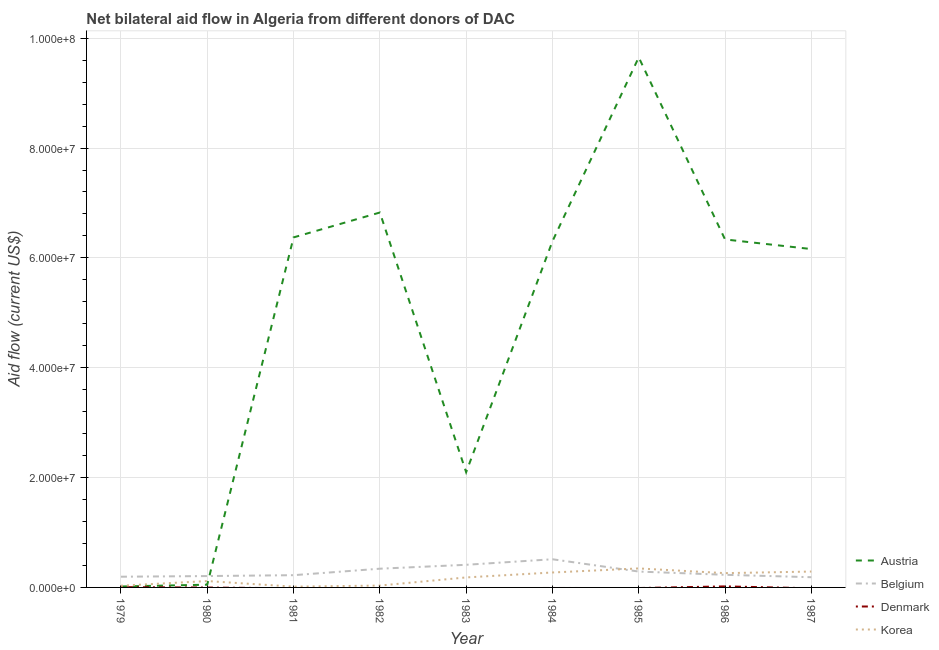What is the amount of aid given by belgium in 1987?
Offer a terse response. 1.86e+06. Across all years, what is the maximum amount of aid given by austria?
Keep it short and to the point. 9.65e+07. Across all years, what is the minimum amount of aid given by austria?
Keep it short and to the point. 1.70e+05. In which year was the amount of aid given by austria maximum?
Your response must be concise. 1985. What is the total amount of aid given by belgium in the graph?
Your answer should be compact. 2.60e+07. What is the difference between the amount of aid given by austria in 1981 and that in 1983?
Your response must be concise. 4.28e+07. What is the difference between the amount of aid given by korea in 1979 and the amount of aid given by denmark in 1980?
Your answer should be compact. 3.10e+05. What is the average amount of aid given by korea per year?
Provide a short and direct response. 1.72e+06. In the year 1981, what is the difference between the amount of aid given by austria and amount of aid given by belgium?
Provide a succinct answer. 6.15e+07. In how many years, is the amount of aid given by denmark greater than 64000000 US$?
Provide a succinct answer. 0. What is the ratio of the amount of aid given by austria in 1983 to that in 1986?
Ensure brevity in your answer.  0.33. Is the amount of aid given by korea in 1983 less than that in 1987?
Give a very brief answer. Yes. What is the difference between the highest and the second highest amount of aid given by korea?
Provide a short and direct response. 5.70e+05. What is the difference between the highest and the lowest amount of aid given by austria?
Offer a terse response. 9.63e+07. In how many years, is the amount of aid given by denmark greater than the average amount of aid given by denmark taken over all years?
Offer a terse response. 2. Is it the case that in every year, the sum of the amount of aid given by austria and amount of aid given by belgium is greater than the amount of aid given by denmark?
Your answer should be compact. Yes. Does the amount of aid given by denmark monotonically increase over the years?
Offer a terse response. No. Is the amount of aid given by denmark strictly greater than the amount of aid given by korea over the years?
Provide a short and direct response. No. Does the graph contain any zero values?
Offer a terse response. Yes. Does the graph contain grids?
Offer a terse response. Yes. Where does the legend appear in the graph?
Provide a succinct answer. Bottom right. How many legend labels are there?
Give a very brief answer. 4. What is the title of the graph?
Ensure brevity in your answer.  Net bilateral aid flow in Algeria from different donors of DAC. What is the label or title of the Y-axis?
Give a very brief answer. Aid flow (current US$). What is the Aid flow (current US$) of Belgium in 1979?
Offer a very short reply. 1.95e+06. What is the Aid flow (current US$) of Denmark in 1979?
Provide a short and direct response. 5.00e+04. What is the Aid flow (current US$) in Korea in 1979?
Make the answer very short. 3.10e+05. What is the Aid flow (current US$) of Austria in 1980?
Keep it short and to the point. 5.00e+05. What is the Aid flow (current US$) of Belgium in 1980?
Your answer should be compact. 2.07e+06. What is the Aid flow (current US$) in Denmark in 1980?
Provide a succinct answer. 0. What is the Aid flow (current US$) of Korea in 1980?
Provide a succinct answer. 1.16e+06. What is the Aid flow (current US$) of Austria in 1981?
Your answer should be compact. 6.37e+07. What is the Aid flow (current US$) in Belgium in 1981?
Your answer should be very brief. 2.23e+06. What is the Aid flow (current US$) in Denmark in 1981?
Offer a very short reply. 0. What is the Aid flow (current US$) in Austria in 1982?
Offer a terse response. 6.83e+07. What is the Aid flow (current US$) in Belgium in 1982?
Your response must be concise. 3.41e+06. What is the Aid flow (current US$) of Austria in 1983?
Offer a very short reply. 2.10e+07. What is the Aid flow (current US$) in Belgium in 1983?
Your response must be concise. 4.12e+06. What is the Aid flow (current US$) in Korea in 1983?
Provide a short and direct response. 1.82e+06. What is the Aid flow (current US$) in Austria in 1984?
Your response must be concise. 6.30e+07. What is the Aid flow (current US$) in Belgium in 1984?
Offer a terse response. 5.13e+06. What is the Aid flow (current US$) in Korea in 1984?
Offer a very short reply. 2.72e+06. What is the Aid flow (current US$) of Austria in 1985?
Make the answer very short. 9.65e+07. What is the Aid flow (current US$) in Belgium in 1985?
Your answer should be compact. 2.89e+06. What is the Aid flow (current US$) in Korea in 1985?
Offer a terse response. 3.46e+06. What is the Aid flow (current US$) of Austria in 1986?
Keep it short and to the point. 6.34e+07. What is the Aid flow (current US$) of Belgium in 1986?
Ensure brevity in your answer.  2.30e+06. What is the Aid flow (current US$) of Denmark in 1986?
Your response must be concise. 1.90e+05. What is the Aid flow (current US$) of Korea in 1986?
Provide a succinct answer. 2.60e+06. What is the Aid flow (current US$) of Austria in 1987?
Ensure brevity in your answer.  6.16e+07. What is the Aid flow (current US$) in Belgium in 1987?
Your response must be concise. 1.86e+06. What is the Aid flow (current US$) of Denmark in 1987?
Offer a very short reply. 0. What is the Aid flow (current US$) in Korea in 1987?
Make the answer very short. 2.89e+06. Across all years, what is the maximum Aid flow (current US$) of Austria?
Provide a short and direct response. 9.65e+07. Across all years, what is the maximum Aid flow (current US$) of Belgium?
Your answer should be compact. 5.13e+06. Across all years, what is the maximum Aid flow (current US$) in Denmark?
Provide a succinct answer. 1.90e+05. Across all years, what is the maximum Aid flow (current US$) of Korea?
Give a very brief answer. 3.46e+06. Across all years, what is the minimum Aid flow (current US$) of Belgium?
Your answer should be compact. 1.86e+06. What is the total Aid flow (current US$) in Austria in the graph?
Offer a terse response. 4.38e+08. What is the total Aid flow (current US$) in Belgium in the graph?
Your answer should be compact. 2.60e+07. What is the total Aid flow (current US$) in Denmark in the graph?
Offer a terse response. 2.40e+05. What is the total Aid flow (current US$) of Korea in the graph?
Your answer should be compact. 1.54e+07. What is the difference between the Aid flow (current US$) in Austria in 1979 and that in 1980?
Your response must be concise. -3.30e+05. What is the difference between the Aid flow (current US$) in Belgium in 1979 and that in 1980?
Offer a very short reply. -1.20e+05. What is the difference between the Aid flow (current US$) of Korea in 1979 and that in 1980?
Make the answer very short. -8.50e+05. What is the difference between the Aid flow (current US$) in Austria in 1979 and that in 1981?
Offer a very short reply. -6.36e+07. What is the difference between the Aid flow (current US$) of Belgium in 1979 and that in 1981?
Ensure brevity in your answer.  -2.80e+05. What is the difference between the Aid flow (current US$) in Korea in 1979 and that in 1981?
Give a very brief answer. 1.70e+05. What is the difference between the Aid flow (current US$) in Austria in 1979 and that in 1982?
Offer a very short reply. -6.81e+07. What is the difference between the Aid flow (current US$) of Belgium in 1979 and that in 1982?
Offer a very short reply. -1.46e+06. What is the difference between the Aid flow (current US$) in Austria in 1979 and that in 1983?
Provide a short and direct response. -2.08e+07. What is the difference between the Aid flow (current US$) of Belgium in 1979 and that in 1983?
Your answer should be very brief. -2.17e+06. What is the difference between the Aid flow (current US$) of Korea in 1979 and that in 1983?
Make the answer very short. -1.51e+06. What is the difference between the Aid flow (current US$) in Austria in 1979 and that in 1984?
Keep it short and to the point. -6.28e+07. What is the difference between the Aid flow (current US$) of Belgium in 1979 and that in 1984?
Your response must be concise. -3.18e+06. What is the difference between the Aid flow (current US$) in Korea in 1979 and that in 1984?
Your response must be concise. -2.41e+06. What is the difference between the Aid flow (current US$) of Austria in 1979 and that in 1985?
Your answer should be compact. -9.63e+07. What is the difference between the Aid flow (current US$) in Belgium in 1979 and that in 1985?
Ensure brevity in your answer.  -9.40e+05. What is the difference between the Aid flow (current US$) of Korea in 1979 and that in 1985?
Provide a succinct answer. -3.15e+06. What is the difference between the Aid flow (current US$) of Austria in 1979 and that in 1986?
Give a very brief answer. -6.32e+07. What is the difference between the Aid flow (current US$) in Belgium in 1979 and that in 1986?
Your answer should be compact. -3.50e+05. What is the difference between the Aid flow (current US$) of Korea in 1979 and that in 1986?
Your answer should be very brief. -2.29e+06. What is the difference between the Aid flow (current US$) in Austria in 1979 and that in 1987?
Keep it short and to the point. -6.14e+07. What is the difference between the Aid flow (current US$) of Belgium in 1979 and that in 1987?
Provide a succinct answer. 9.00e+04. What is the difference between the Aid flow (current US$) in Korea in 1979 and that in 1987?
Give a very brief answer. -2.58e+06. What is the difference between the Aid flow (current US$) in Austria in 1980 and that in 1981?
Offer a terse response. -6.32e+07. What is the difference between the Aid flow (current US$) in Belgium in 1980 and that in 1981?
Keep it short and to the point. -1.60e+05. What is the difference between the Aid flow (current US$) in Korea in 1980 and that in 1981?
Your response must be concise. 1.02e+06. What is the difference between the Aid flow (current US$) of Austria in 1980 and that in 1982?
Your response must be concise. -6.78e+07. What is the difference between the Aid flow (current US$) in Belgium in 1980 and that in 1982?
Offer a very short reply. -1.34e+06. What is the difference between the Aid flow (current US$) in Korea in 1980 and that in 1982?
Give a very brief answer. 8.20e+05. What is the difference between the Aid flow (current US$) in Austria in 1980 and that in 1983?
Provide a short and direct response. -2.05e+07. What is the difference between the Aid flow (current US$) of Belgium in 1980 and that in 1983?
Your answer should be compact. -2.05e+06. What is the difference between the Aid flow (current US$) in Korea in 1980 and that in 1983?
Offer a terse response. -6.60e+05. What is the difference between the Aid flow (current US$) in Austria in 1980 and that in 1984?
Offer a terse response. -6.25e+07. What is the difference between the Aid flow (current US$) in Belgium in 1980 and that in 1984?
Provide a succinct answer. -3.06e+06. What is the difference between the Aid flow (current US$) of Korea in 1980 and that in 1984?
Make the answer very short. -1.56e+06. What is the difference between the Aid flow (current US$) of Austria in 1980 and that in 1985?
Provide a succinct answer. -9.60e+07. What is the difference between the Aid flow (current US$) in Belgium in 1980 and that in 1985?
Offer a terse response. -8.20e+05. What is the difference between the Aid flow (current US$) of Korea in 1980 and that in 1985?
Offer a very short reply. -2.30e+06. What is the difference between the Aid flow (current US$) of Austria in 1980 and that in 1986?
Your response must be concise. -6.29e+07. What is the difference between the Aid flow (current US$) in Korea in 1980 and that in 1986?
Your answer should be very brief. -1.44e+06. What is the difference between the Aid flow (current US$) of Austria in 1980 and that in 1987?
Your answer should be very brief. -6.11e+07. What is the difference between the Aid flow (current US$) in Korea in 1980 and that in 1987?
Provide a succinct answer. -1.73e+06. What is the difference between the Aid flow (current US$) in Austria in 1981 and that in 1982?
Give a very brief answer. -4.53e+06. What is the difference between the Aid flow (current US$) in Belgium in 1981 and that in 1982?
Offer a very short reply. -1.18e+06. What is the difference between the Aid flow (current US$) of Korea in 1981 and that in 1982?
Make the answer very short. -2.00e+05. What is the difference between the Aid flow (current US$) in Austria in 1981 and that in 1983?
Make the answer very short. 4.28e+07. What is the difference between the Aid flow (current US$) in Belgium in 1981 and that in 1983?
Provide a short and direct response. -1.89e+06. What is the difference between the Aid flow (current US$) of Korea in 1981 and that in 1983?
Provide a short and direct response. -1.68e+06. What is the difference between the Aid flow (current US$) of Austria in 1981 and that in 1984?
Keep it short and to the point. 7.10e+05. What is the difference between the Aid flow (current US$) in Belgium in 1981 and that in 1984?
Keep it short and to the point. -2.90e+06. What is the difference between the Aid flow (current US$) of Korea in 1981 and that in 1984?
Provide a succinct answer. -2.58e+06. What is the difference between the Aid flow (current US$) in Austria in 1981 and that in 1985?
Ensure brevity in your answer.  -3.28e+07. What is the difference between the Aid flow (current US$) in Belgium in 1981 and that in 1985?
Keep it short and to the point. -6.60e+05. What is the difference between the Aid flow (current US$) in Korea in 1981 and that in 1985?
Provide a succinct answer. -3.32e+06. What is the difference between the Aid flow (current US$) in Korea in 1981 and that in 1986?
Offer a very short reply. -2.46e+06. What is the difference between the Aid flow (current US$) in Austria in 1981 and that in 1987?
Give a very brief answer. 2.12e+06. What is the difference between the Aid flow (current US$) of Belgium in 1981 and that in 1987?
Give a very brief answer. 3.70e+05. What is the difference between the Aid flow (current US$) in Korea in 1981 and that in 1987?
Provide a short and direct response. -2.75e+06. What is the difference between the Aid flow (current US$) in Austria in 1982 and that in 1983?
Keep it short and to the point. 4.73e+07. What is the difference between the Aid flow (current US$) in Belgium in 1982 and that in 1983?
Offer a terse response. -7.10e+05. What is the difference between the Aid flow (current US$) of Korea in 1982 and that in 1983?
Your answer should be very brief. -1.48e+06. What is the difference between the Aid flow (current US$) in Austria in 1982 and that in 1984?
Your answer should be compact. 5.24e+06. What is the difference between the Aid flow (current US$) in Belgium in 1982 and that in 1984?
Ensure brevity in your answer.  -1.72e+06. What is the difference between the Aid flow (current US$) in Korea in 1982 and that in 1984?
Provide a succinct answer. -2.38e+06. What is the difference between the Aid flow (current US$) of Austria in 1982 and that in 1985?
Make the answer very short. -2.82e+07. What is the difference between the Aid flow (current US$) of Belgium in 1982 and that in 1985?
Your answer should be very brief. 5.20e+05. What is the difference between the Aid flow (current US$) of Korea in 1982 and that in 1985?
Ensure brevity in your answer.  -3.12e+06. What is the difference between the Aid flow (current US$) in Austria in 1982 and that in 1986?
Keep it short and to the point. 4.90e+06. What is the difference between the Aid flow (current US$) of Belgium in 1982 and that in 1986?
Your response must be concise. 1.11e+06. What is the difference between the Aid flow (current US$) of Korea in 1982 and that in 1986?
Give a very brief answer. -2.26e+06. What is the difference between the Aid flow (current US$) in Austria in 1982 and that in 1987?
Your answer should be very brief. 6.65e+06. What is the difference between the Aid flow (current US$) of Belgium in 1982 and that in 1987?
Ensure brevity in your answer.  1.55e+06. What is the difference between the Aid flow (current US$) of Korea in 1982 and that in 1987?
Provide a succinct answer. -2.55e+06. What is the difference between the Aid flow (current US$) of Austria in 1983 and that in 1984?
Your answer should be compact. -4.20e+07. What is the difference between the Aid flow (current US$) in Belgium in 1983 and that in 1984?
Keep it short and to the point. -1.01e+06. What is the difference between the Aid flow (current US$) of Korea in 1983 and that in 1984?
Give a very brief answer. -9.00e+05. What is the difference between the Aid flow (current US$) of Austria in 1983 and that in 1985?
Offer a very short reply. -7.55e+07. What is the difference between the Aid flow (current US$) in Belgium in 1983 and that in 1985?
Provide a short and direct response. 1.23e+06. What is the difference between the Aid flow (current US$) in Korea in 1983 and that in 1985?
Provide a succinct answer. -1.64e+06. What is the difference between the Aid flow (current US$) in Austria in 1983 and that in 1986?
Ensure brevity in your answer.  -4.24e+07. What is the difference between the Aid flow (current US$) in Belgium in 1983 and that in 1986?
Give a very brief answer. 1.82e+06. What is the difference between the Aid flow (current US$) of Korea in 1983 and that in 1986?
Your answer should be compact. -7.80e+05. What is the difference between the Aid flow (current US$) of Austria in 1983 and that in 1987?
Offer a very short reply. -4.06e+07. What is the difference between the Aid flow (current US$) in Belgium in 1983 and that in 1987?
Ensure brevity in your answer.  2.26e+06. What is the difference between the Aid flow (current US$) in Korea in 1983 and that in 1987?
Provide a succinct answer. -1.07e+06. What is the difference between the Aid flow (current US$) in Austria in 1984 and that in 1985?
Your response must be concise. -3.35e+07. What is the difference between the Aid flow (current US$) in Belgium in 1984 and that in 1985?
Provide a succinct answer. 2.24e+06. What is the difference between the Aid flow (current US$) of Korea in 1984 and that in 1985?
Your answer should be compact. -7.40e+05. What is the difference between the Aid flow (current US$) in Belgium in 1984 and that in 1986?
Your answer should be very brief. 2.83e+06. What is the difference between the Aid flow (current US$) of Austria in 1984 and that in 1987?
Provide a short and direct response. 1.41e+06. What is the difference between the Aid flow (current US$) of Belgium in 1984 and that in 1987?
Ensure brevity in your answer.  3.27e+06. What is the difference between the Aid flow (current US$) of Austria in 1985 and that in 1986?
Keep it short and to the point. 3.32e+07. What is the difference between the Aid flow (current US$) in Belgium in 1985 and that in 1986?
Make the answer very short. 5.90e+05. What is the difference between the Aid flow (current US$) in Korea in 1985 and that in 1986?
Offer a terse response. 8.60e+05. What is the difference between the Aid flow (current US$) in Austria in 1985 and that in 1987?
Your answer should be compact. 3.49e+07. What is the difference between the Aid flow (current US$) of Belgium in 1985 and that in 1987?
Your answer should be very brief. 1.03e+06. What is the difference between the Aid flow (current US$) in Korea in 1985 and that in 1987?
Offer a terse response. 5.70e+05. What is the difference between the Aid flow (current US$) of Austria in 1986 and that in 1987?
Your answer should be very brief. 1.75e+06. What is the difference between the Aid flow (current US$) in Korea in 1986 and that in 1987?
Ensure brevity in your answer.  -2.90e+05. What is the difference between the Aid flow (current US$) of Austria in 1979 and the Aid flow (current US$) of Belgium in 1980?
Provide a succinct answer. -1.90e+06. What is the difference between the Aid flow (current US$) of Austria in 1979 and the Aid flow (current US$) of Korea in 1980?
Offer a terse response. -9.90e+05. What is the difference between the Aid flow (current US$) in Belgium in 1979 and the Aid flow (current US$) in Korea in 1980?
Offer a terse response. 7.90e+05. What is the difference between the Aid flow (current US$) in Denmark in 1979 and the Aid flow (current US$) in Korea in 1980?
Provide a short and direct response. -1.11e+06. What is the difference between the Aid flow (current US$) of Austria in 1979 and the Aid flow (current US$) of Belgium in 1981?
Give a very brief answer. -2.06e+06. What is the difference between the Aid flow (current US$) of Belgium in 1979 and the Aid flow (current US$) of Korea in 1981?
Ensure brevity in your answer.  1.81e+06. What is the difference between the Aid flow (current US$) of Austria in 1979 and the Aid flow (current US$) of Belgium in 1982?
Your answer should be compact. -3.24e+06. What is the difference between the Aid flow (current US$) of Belgium in 1979 and the Aid flow (current US$) of Korea in 1982?
Make the answer very short. 1.61e+06. What is the difference between the Aid flow (current US$) of Austria in 1979 and the Aid flow (current US$) of Belgium in 1983?
Provide a succinct answer. -3.95e+06. What is the difference between the Aid flow (current US$) of Austria in 1979 and the Aid flow (current US$) of Korea in 1983?
Keep it short and to the point. -1.65e+06. What is the difference between the Aid flow (current US$) of Denmark in 1979 and the Aid flow (current US$) of Korea in 1983?
Keep it short and to the point. -1.77e+06. What is the difference between the Aid flow (current US$) in Austria in 1979 and the Aid flow (current US$) in Belgium in 1984?
Offer a terse response. -4.96e+06. What is the difference between the Aid flow (current US$) of Austria in 1979 and the Aid flow (current US$) of Korea in 1984?
Provide a succinct answer. -2.55e+06. What is the difference between the Aid flow (current US$) of Belgium in 1979 and the Aid flow (current US$) of Korea in 1984?
Your answer should be compact. -7.70e+05. What is the difference between the Aid flow (current US$) of Denmark in 1979 and the Aid flow (current US$) of Korea in 1984?
Make the answer very short. -2.67e+06. What is the difference between the Aid flow (current US$) of Austria in 1979 and the Aid flow (current US$) of Belgium in 1985?
Your answer should be very brief. -2.72e+06. What is the difference between the Aid flow (current US$) of Austria in 1979 and the Aid flow (current US$) of Korea in 1985?
Offer a very short reply. -3.29e+06. What is the difference between the Aid flow (current US$) in Belgium in 1979 and the Aid flow (current US$) in Korea in 1985?
Your answer should be very brief. -1.51e+06. What is the difference between the Aid flow (current US$) in Denmark in 1979 and the Aid flow (current US$) in Korea in 1985?
Provide a succinct answer. -3.41e+06. What is the difference between the Aid flow (current US$) in Austria in 1979 and the Aid flow (current US$) in Belgium in 1986?
Your answer should be very brief. -2.13e+06. What is the difference between the Aid flow (current US$) of Austria in 1979 and the Aid flow (current US$) of Korea in 1986?
Offer a terse response. -2.43e+06. What is the difference between the Aid flow (current US$) in Belgium in 1979 and the Aid flow (current US$) in Denmark in 1986?
Your response must be concise. 1.76e+06. What is the difference between the Aid flow (current US$) in Belgium in 1979 and the Aid flow (current US$) in Korea in 1986?
Keep it short and to the point. -6.50e+05. What is the difference between the Aid flow (current US$) in Denmark in 1979 and the Aid flow (current US$) in Korea in 1986?
Provide a succinct answer. -2.55e+06. What is the difference between the Aid flow (current US$) in Austria in 1979 and the Aid flow (current US$) in Belgium in 1987?
Offer a very short reply. -1.69e+06. What is the difference between the Aid flow (current US$) in Austria in 1979 and the Aid flow (current US$) in Korea in 1987?
Offer a terse response. -2.72e+06. What is the difference between the Aid flow (current US$) of Belgium in 1979 and the Aid flow (current US$) of Korea in 1987?
Your response must be concise. -9.40e+05. What is the difference between the Aid flow (current US$) in Denmark in 1979 and the Aid flow (current US$) in Korea in 1987?
Provide a succinct answer. -2.84e+06. What is the difference between the Aid flow (current US$) in Austria in 1980 and the Aid flow (current US$) in Belgium in 1981?
Offer a very short reply. -1.73e+06. What is the difference between the Aid flow (current US$) of Belgium in 1980 and the Aid flow (current US$) of Korea in 1981?
Make the answer very short. 1.93e+06. What is the difference between the Aid flow (current US$) in Austria in 1980 and the Aid flow (current US$) in Belgium in 1982?
Offer a very short reply. -2.91e+06. What is the difference between the Aid flow (current US$) of Austria in 1980 and the Aid flow (current US$) of Korea in 1982?
Make the answer very short. 1.60e+05. What is the difference between the Aid flow (current US$) in Belgium in 1980 and the Aid flow (current US$) in Korea in 1982?
Keep it short and to the point. 1.73e+06. What is the difference between the Aid flow (current US$) of Austria in 1980 and the Aid flow (current US$) of Belgium in 1983?
Ensure brevity in your answer.  -3.62e+06. What is the difference between the Aid flow (current US$) in Austria in 1980 and the Aid flow (current US$) in Korea in 1983?
Offer a very short reply. -1.32e+06. What is the difference between the Aid flow (current US$) in Austria in 1980 and the Aid flow (current US$) in Belgium in 1984?
Provide a succinct answer. -4.63e+06. What is the difference between the Aid flow (current US$) in Austria in 1980 and the Aid flow (current US$) in Korea in 1984?
Offer a terse response. -2.22e+06. What is the difference between the Aid flow (current US$) in Belgium in 1980 and the Aid flow (current US$) in Korea in 1984?
Your response must be concise. -6.50e+05. What is the difference between the Aid flow (current US$) in Austria in 1980 and the Aid flow (current US$) in Belgium in 1985?
Keep it short and to the point. -2.39e+06. What is the difference between the Aid flow (current US$) in Austria in 1980 and the Aid flow (current US$) in Korea in 1985?
Provide a succinct answer. -2.96e+06. What is the difference between the Aid flow (current US$) in Belgium in 1980 and the Aid flow (current US$) in Korea in 1985?
Offer a terse response. -1.39e+06. What is the difference between the Aid flow (current US$) in Austria in 1980 and the Aid flow (current US$) in Belgium in 1986?
Make the answer very short. -1.80e+06. What is the difference between the Aid flow (current US$) of Austria in 1980 and the Aid flow (current US$) of Denmark in 1986?
Give a very brief answer. 3.10e+05. What is the difference between the Aid flow (current US$) of Austria in 1980 and the Aid flow (current US$) of Korea in 1986?
Provide a succinct answer. -2.10e+06. What is the difference between the Aid flow (current US$) in Belgium in 1980 and the Aid flow (current US$) in Denmark in 1986?
Your answer should be very brief. 1.88e+06. What is the difference between the Aid flow (current US$) of Belgium in 1980 and the Aid flow (current US$) of Korea in 1986?
Your answer should be very brief. -5.30e+05. What is the difference between the Aid flow (current US$) in Austria in 1980 and the Aid flow (current US$) in Belgium in 1987?
Your answer should be very brief. -1.36e+06. What is the difference between the Aid flow (current US$) in Austria in 1980 and the Aid flow (current US$) in Korea in 1987?
Your response must be concise. -2.39e+06. What is the difference between the Aid flow (current US$) of Belgium in 1980 and the Aid flow (current US$) of Korea in 1987?
Your answer should be very brief. -8.20e+05. What is the difference between the Aid flow (current US$) in Austria in 1981 and the Aid flow (current US$) in Belgium in 1982?
Provide a succinct answer. 6.03e+07. What is the difference between the Aid flow (current US$) in Austria in 1981 and the Aid flow (current US$) in Korea in 1982?
Your answer should be very brief. 6.34e+07. What is the difference between the Aid flow (current US$) in Belgium in 1981 and the Aid flow (current US$) in Korea in 1982?
Provide a short and direct response. 1.89e+06. What is the difference between the Aid flow (current US$) in Austria in 1981 and the Aid flow (current US$) in Belgium in 1983?
Keep it short and to the point. 5.96e+07. What is the difference between the Aid flow (current US$) in Austria in 1981 and the Aid flow (current US$) in Korea in 1983?
Your answer should be compact. 6.19e+07. What is the difference between the Aid flow (current US$) in Belgium in 1981 and the Aid flow (current US$) in Korea in 1983?
Ensure brevity in your answer.  4.10e+05. What is the difference between the Aid flow (current US$) in Austria in 1981 and the Aid flow (current US$) in Belgium in 1984?
Make the answer very short. 5.86e+07. What is the difference between the Aid flow (current US$) of Austria in 1981 and the Aid flow (current US$) of Korea in 1984?
Make the answer very short. 6.10e+07. What is the difference between the Aid flow (current US$) in Belgium in 1981 and the Aid flow (current US$) in Korea in 1984?
Your answer should be compact. -4.90e+05. What is the difference between the Aid flow (current US$) of Austria in 1981 and the Aid flow (current US$) of Belgium in 1985?
Keep it short and to the point. 6.08e+07. What is the difference between the Aid flow (current US$) in Austria in 1981 and the Aid flow (current US$) in Korea in 1985?
Keep it short and to the point. 6.03e+07. What is the difference between the Aid flow (current US$) of Belgium in 1981 and the Aid flow (current US$) of Korea in 1985?
Give a very brief answer. -1.23e+06. What is the difference between the Aid flow (current US$) of Austria in 1981 and the Aid flow (current US$) of Belgium in 1986?
Provide a short and direct response. 6.14e+07. What is the difference between the Aid flow (current US$) in Austria in 1981 and the Aid flow (current US$) in Denmark in 1986?
Your response must be concise. 6.35e+07. What is the difference between the Aid flow (current US$) of Austria in 1981 and the Aid flow (current US$) of Korea in 1986?
Keep it short and to the point. 6.11e+07. What is the difference between the Aid flow (current US$) in Belgium in 1981 and the Aid flow (current US$) in Denmark in 1986?
Provide a short and direct response. 2.04e+06. What is the difference between the Aid flow (current US$) in Belgium in 1981 and the Aid flow (current US$) in Korea in 1986?
Offer a very short reply. -3.70e+05. What is the difference between the Aid flow (current US$) of Austria in 1981 and the Aid flow (current US$) of Belgium in 1987?
Your answer should be compact. 6.19e+07. What is the difference between the Aid flow (current US$) in Austria in 1981 and the Aid flow (current US$) in Korea in 1987?
Keep it short and to the point. 6.08e+07. What is the difference between the Aid flow (current US$) of Belgium in 1981 and the Aid flow (current US$) of Korea in 1987?
Offer a very short reply. -6.60e+05. What is the difference between the Aid flow (current US$) in Austria in 1982 and the Aid flow (current US$) in Belgium in 1983?
Your answer should be compact. 6.41e+07. What is the difference between the Aid flow (current US$) in Austria in 1982 and the Aid flow (current US$) in Korea in 1983?
Ensure brevity in your answer.  6.64e+07. What is the difference between the Aid flow (current US$) in Belgium in 1982 and the Aid flow (current US$) in Korea in 1983?
Make the answer very short. 1.59e+06. What is the difference between the Aid flow (current US$) of Austria in 1982 and the Aid flow (current US$) of Belgium in 1984?
Your answer should be compact. 6.31e+07. What is the difference between the Aid flow (current US$) of Austria in 1982 and the Aid flow (current US$) of Korea in 1984?
Keep it short and to the point. 6.55e+07. What is the difference between the Aid flow (current US$) of Belgium in 1982 and the Aid flow (current US$) of Korea in 1984?
Provide a succinct answer. 6.90e+05. What is the difference between the Aid flow (current US$) in Austria in 1982 and the Aid flow (current US$) in Belgium in 1985?
Ensure brevity in your answer.  6.54e+07. What is the difference between the Aid flow (current US$) in Austria in 1982 and the Aid flow (current US$) in Korea in 1985?
Your response must be concise. 6.48e+07. What is the difference between the Aid flow (current US$) in Belgium in 1982 and the Aid flow (current US$) in Korea in 1985?
Make the answer very short. -5.00e+04. What is the difference between the Aid flow (current US$) of Austria in 1982 and the Aid flow (current US$) of Belgium in 1986?
Give a very brief answer. 6.60e+07. What is the difference between the Aid flow (current US$) of Austria in 1982 and the Aid flow (current US$) of Denmark in 1986?
Offer a terse response. 6.81e+07. What is the difference between the Aid flow (current US$) of Austria in 1982 and the Aid flow (current US$) of Korea in 1986?
Provide a short and direct response. 6.57e+07. What is the difference between the Aid flow (current US$) in Belgium in 1982 and the Aid flow (current US$) in Denmark in 1986?
Your answer should be compact. 3.22e+06. What is the difference between the Aid flow (current US$) in Belgium in 1982 and the Aid flow (current US$) in Korea in 1986?
Give a very brief answer. 8.10e+05. What is the difference between the Aid flow (current US$) in Austria in 1982 and the Aid flow (current US$) in Belgium in 1987?
Keep it short and to the point. 6.64e+07. What is the difference between the Aid flow (current US$) in Austria in 1982 and the Aid flow (current US$) in Korea in 1987?
Provide a short and direct response. 6.54e+07. What is the difference between the Aid flow (current US$) in Belgium in 1982 and the Aid flow (current US$) in Korea in 1987?
Give a very brief answer. 5.20e+05. What is the difference between the Aid flow (current US$) in Austria in 1983 and the Aid flow (current US$) in Belgium in 1984?
Provide a succinct answer. 1.58e+07. What is the difference between the Aid flow (current US$) of Austria in 1983 and the Aid flow (current US$) of Korea in 1984?
Make the answer very short. 1.83e+07. What is the difference between the Aid flow (current US$) of Belgium in 1983 and the Aid flow (current US$) of Korea in 1984?
Ensure brevity in your answer.  1.40e+06. What is the difference between the Aid flow (current US$) of Austria in 1983 and the Aid flow (current US$) of Belgium in 1985?
Give a very brief answer. 1.81e+07. What is the difference between the Aid flow (current US$) in Austria in 1983 and the Aid flow (current US$) in Korea in 1985?
Keep it short and to the point. 1.75e+07. What is the difference between the Aid flow (current US$) in Belgium in 1983 and the Aid flow (current US$) in Korea in 1985?
Ensure brevity in your answer.  6.60e+05. What is the difference between the Aid flow (current US$) of Austria in 1983 and the Aid flow (current US$) of Belgium in 1986?
Your response must be concise. 1.87e+07. What is the difference between the Aid flow (current US$) of Austria in 1983 and the Aid flow (current US$) of Denmark in 1986?
Ensure brevity in your answer.  2.08e+07. What is the difference between the Aid flow (current US$) in Austria in 1983 and the Aid flow (current US$) in Korea in 1986?
Your answer should be compact. 1.84e+07. What is the difference between the Aid flow (current US$) in Belgium in 1983 and the Aid flow (current US$) in Denmark in 1986?
Your answer should be very brief. 3.93e+06. What is the difference between the Aid flow (current US$) in Belgium in 1983 and the Aid flow (current US$) in Korea in 1986?
Make the answer very short. 1.52e+06. What is the difference between the Aid flow (current US$) of Austria in 1983 and the Aid flow (current US$) of Belgium in 1987?
Offer a very short reply. 1.91e+07. What is the difference between the Aid flow (current US$) in Austria in 1983 and the Aid flow (current US$) in Korea in 1987?
Offer a very short reply. 1.81e+07. What is the difference between the Aid flow (current US$) in Belgium in 1983 and the Aid flow (current US$) in Korea in 1987?
Your response must be concise. 1.23e+06. What is the difference between the Aid flow (current US$) in Austria in 1984 and the Aid flow (current US$) in Belgium in 1985?
Offer a terse response. 6.01e+07. What is the difference between the Aid flow (current US$) of Austria in 1984 and the Aid flow (current US$) of Korea in 1985?
Keep it short and to the point. 5.96e+07. What is the difference between the Aid flow (current US$) of Belgium in 1984 and the Aid flow (current US$) of Korea in 1985?
Offer a very short reply. 1.67e+06. What is the difference between the Aid flow (current US$) in Austria in 1984 and the Aid flow (current US$) in Belgium in 1986?
Your response must be concise. 6.07e+07. What is the difference between the Aid flow (current US$) in Austria in 1984 and the Aid flow (current US$) in Denmark in 1986?
Give a very brief answer. 6.28e+07. What is the difference between the Aid flow (current US$) in Austria in 1984 and the Aid flow (current US$) in Korea in 1986?
Give a very brief answer. 6.04e+07. What is the difference between the Aid flow (current US$) in Belgium in 1984 and the Aid flow (current US$) in Denmark in 1986?
Your response must be concise. 4.94e+06. What is the difference between the Aid flow (current US$) of Belgium in 1984 and the Aid flow (current US$) of Korea in 1986?
Your response must be concise. 2.53e+06. What is the difference between the Aid flow (current US$) in Austria in 1984 and the Aid flow (current US$) in Belgium in 1987?
Give a very brief answer. 6.12e+07. What is the difference between the Aid flow (current US$) of Austria in 1984 and the Aid flow (current US$) of Korea in 1987?
Offer a very short reply. 6.01e+07. What is the difference between the Aid flow (current US$) in Belgium in 1984 and the Aid flow (current US$) in Korea in 1987?
Your response must be concise. 2.24e+06. What is the difference between the Aid flow (current US$) in Austria in 1985 and the Aid flow (current US$) in Belgium in 1986?
Keep it short and to the point. 9.42e+07. What is the difference between the Aid flow (current US$) in Austria in 1985 and the Aid flow (current US$) in Denmark in 1986?
Provide a succinct answer. 9.63e+07. What is the difference between the Aid flow (current US$) in Austria in 1985 and the Aid flow (current US$) in Korea in 1986?
Your answer should be very brief. 9.39e+07. What is the difference between the Aid flow (current US$) in Belgium in 1985 and the Aid flow (current US$) in Denmark in 1986?
Provide a short and direct response. 2.70e+06. What is the difference between the Aid flow (current US$) of Austria in 1985 and the Aid flow (current US$) of Belgium in 1987?
Provide a succinct answer. 9.46e+07. What is the difference between the Aid flow (current US$) in Austria in 1985 and the Aid flow (current US$) in Korea in 1987?
Make the answer very short. 9.36e+07. What is the difference between the Aid flow (current US$) of Austria in 1986 and the Aid flow (current US$) of Belgium in 1987?
Your response must be concise. 6.15e+07. What is the difference between the Aid flow (current US$) of Austria in 1986 and the Aid flow (current US$) of Korea in 1987?
Your answer should be compact. 6.05e+07. What is the difference between the Aid flow (current US$) in Belgium in 1986 and the Aid flow (current US$) in Korea in 1987?
Give a very brief answer. -5.90e+05. What is the difference between the Aid flow (current US$) in Denmark in 1986 and the Aid flow (current US$) in Korea in 1987?
Keep it short and to the point. -2.70e+06. What is the average Aid flow (current US$) of Austria per year?
Keep it short and to the point. 4.87e+07. What is the average Aid flow (current US$) of Belgium per year?
Give a very brief answer. 2.88e+06. What is the average Aid flow (current US$) of Denmark per year?
Make the answer very short. 2.67e+04. What is the average Aid flow (current US$) of Korea per year?
Make the answer very short. 1.72e+06. In the year 1979, what is the difference between the Aid flow (current US$) in Austria and Aid flow (current US$) in Belgium?
Offer a very short reply. -1.78e+06. In the year 1979, what is the difference between the Aid flow (current US$) in Austria and Aid flow (current US$) in Denmark?
Your response must be concise. 1.20e+05. In the year 1979, what is the difference between the Aid flow (current US$) of Belgium and Aid flow (current US$) of Denmark?
Provide a short and direct response. 1.90e+06. In the year 1979, what is the difference between the Aid flow (current US$) of Belgium and Aid flow (current US$) of Korea?
Ensure brevity in your answer.  1.64e+06. In the year 1980, what is the difference between the Aid flow (current US$) in Austria and Aid flow (current US$) in Belgium?
Your answer should be compact. -1.57e+06. In the year 1980, what is the difference between the Aid flow (current US$) of Austria and Aid flow (current US$) of Korea?
Ensure brevity in your answer.  -6.60e+05. In the year 1980, what is the difference between the Aid flow (current US$) of Belgium and Aid flow (current US$) of Korea?
Keep it short and to the point. 9.10e+05. In the year 1981, what is the difference between the Aid flow (current US$) in Austria and Aid flow (current US$) in Belgium?
Offer a very short reply. 6.15e+07. In the year 1981, what is the difference between the Aid flow (current US$) in Austria and Aid flow (current US$) in Korea?
Make the answer very short. 6.36e+07. In the year 1981, what is the difference between the Aid flow (current US$) in Belgium and Aid flow (current US$) in Korea?
Make the answer very short. 2.09e+06. In the year 1982, what is the difference between the Aid flow (current US$) of Austria and Aid flow (current US$) of Belgium?
Keep it short and to the point. 6.48e+07. In the year 1982, what is the difference between the Aid flow (current US$) in Austria and Aid flow (current US$) in Korea?
Your answer should be compact. 6.79e+07. In the year 1982, what is the difference between the Aid flow (current US$) of Belgium and Aid flow (current US$) of Korea?
Your answer should be compact. 3.07e+06. In the year 1983, what is the difference between the Aid flow (current US$) in Austria and Aid flow (current US$) in Belgium?
Give a very brief answer. 1.69e+07. In the year 1983, what is the difference between the Aid flow (current US$) of Austria and Aid flow (current US$) of Korea?
Ensure brevity in your answer.  1.92e+07. In the year 1983, what is the difference between the Aid flow (current US$) in Belgium and Aid flow (current US$) in Korea?
Provide a succinct answer. 2.30e+06. In the year 1984, what is the difference between the Aid flow (current US$) of Austria and Aid flow (current US$) of Belgium?
Keep it short and to the point. 5.79e+07. In the year 1984, what is the difference between the Aid flow (current US$) of Austria and Aid flow (current US$) of Korea?
Keep it short and to the point. 6.03e+07. In the year 1984, what is the difference between the Aid flow (current US$) of Belgium and Aid flow (current US$) of Korea?
Your answer should be compact. 2.41e+06. In the year 1985, what is the difference between the Aid flow (current US$) in Austria and Aid flow (current US$) in Belgium?
Ensure brevity in your answer.  9.36e+07. In the year 1985, what is the difference between the Aid flow (current US$) in Austria and Aid flow (current US$) in Korea?
Provide a short and direct response. 9.30e+07. In the year 1985, what is the difference between the Aid flow (current US$) of Belgium and Aid flow (current US$) of Korea?
Your answer should be compact. -5.70e+05. In the year 1986, what is the difference between the Aid flow (current US$) in Austria and Aid flow (current US$) in Belgium?
Provide a short and direct response. 6.11e+07. In the year 1986, what is the difference between the Aid flow (current US$) in Austria and Aid flow (current US$) in Denmark?
Offer a terse response. 6.32e+07. In the year 1986, what is the difference between the Aid flow (current US$) in Austria and Aid flow (current US$) in Korea?
Make the answer very short. 6.08e+07. In the year 1986, what is the difference between the Aid flow (current US$) in Belgium and Aid flow (current US$) in Denmark?
Keep it short and to the point. 2.11e+06. In the year 1986, what is the difference between the Aid flow (current US$) of Belgium and Aid flow (current US$) of Korea?
Your response must be concise. -3.00e+05. In the year 1986, what is the difference between the Aid flow (current US$) in Denmark and Aid flow (current US$) in Korea?
Offer a very short reply. -2.41e+06. In the year 1987, what is the difference between the Aid flow (current US$) of Austria and Aid flow (current US$) of Belgium?
Provide a succinct answer. 5.98e+07. In the year 1987, what is the difference between the Aid flow (current US$) in Austria and Aid flow (current US$) in Korea?
Ensure brevity in your answer.  5.87e+07. In the year 1987, what is the difference between the Aid flow (current US$) of Belgium and Aid flow (current US$) of Korea?
Make the answer very short. -1.03e+06. What is the ratio of the Aid flow (current US$) in Austria in 1979 to that in 1980?
Offer a very short reply. 0.34. What is the ratio of the Aid flow (current US$) of Belgium in 1979 to that in 1980?
Offer a terse response. 0.94. What is the ratio of the Aid flow (current US$) of Korea in 1979 to that in 1980?
Give a very brief answer. 0.27. What is the ratio of the Aid flow (current US$) in Austria in 1979 to that in 1981?
Your answer should be compact. 0. What is the ratio of the Aid flow (current US$) in Belgium in 1979 to that in 1981?
Ensure brevity in your answer.  0.87. What is the ratio of the Aid flow (current US$) of Korea in 1979 to that in 1981?
Offer a very short reply. 2.21. What is the ratio of the Aid flow (current US$) in Austria in 1979 to that in 1982?
Keep it short and to the point. 0. What is the ratio of the Aid flow (current US$) in Belgium in 1979 to that in 1982?
Your answer should be compact. 0.57. What is the ratio of the Aid flow (current US$) of Korea in 1979 to that in 1982?
Your answer should be very brief. 0.91. What is the ratio of the Aid flow (current US$) of Austria in 1979 to that in 1983?
Keep it short and to the point. 0.01. What is the ratio of the Aid flow (current US$) in Belgium in 1979 to that in 1983?
Offer a terse response. 0.47. What is the ratio of the Aid flow (current US$) in Korea in 1979 to that in 1983?
Your answer should be very brief. 0.17. What is the ratio of the Aid flow (current US$) of Austria in 1979 to that in 1984?
Make the answer very short. 0. What is the ratio of the Aid flow (current US$) of Belgium in 1979 to that in 1984?
Your response must be concise. 0.38. What is the ratio of the Aid flow (current US$) in Korea in 1979 to that in 1984?
Your response must be concise. 0.11. What is the ratio of the Aid flow (current US$) in Austria in 1979 to that in 1985?
Your answer should be compact. 0. What is the ratio of the Aid flow (current US$) in Belgium in 1979 to that in 1985?
Your response must be concise. 0.67. What is the ratio of the Aid flow (current US$) of Korea in 1979 to that in 1985?
Your answer should be compact. 0.09. What is the ratio of the Aid flow (current US$) of Austria in 1979 to that in 1986?
Give a very brief answer. 0. What is the ratio of the Aid flow (current US$) in Belgium in 1979 to that in 1986?
Offer a terse response. 0.85. What is the ratio of the Aid flow (current US$) of Denmark in 1979 to that in 1986?
Make the answer very short. 0.26. What is the ratio of the Aid flow (current US$) of Korea in 1979 to that in 1986?
Offer a very short reply. 0.12. What is the ratio of the Aid flow (current US$) in Austria in 1979 to that in 1987?
Make the answer very short. 0. What is the ratio of the Aid flow (current US$) of Belgium in 1979 to that in 1987?
Provide a succinct answer. 1.05. What is the ratio of the Aid flow (current US$) in Korea in 1979 to that in 1987?
Your answer should be very brief. 0.11. What is the ratio of the Aid flow (current US$) of Austria in 1980 to that in 1981?
Offer a very short reply. 0.01. What is the ratio of the Aid flow (current US$) in Belgium in 1980 to that in 1981?
Your answer should be very brief. 0.93. What is the ratio of the Aid flow (current US$) in Korea in 1980 to that in 1981?
Your answer should be compact. 8.29. What is the ratio of the Aid flow (current US$) of Austria in 1980 to that in 1982?
Provide a succinct answer. 0.01. What is the ratio of the Aid flow (current US$) of Belgium in 1980 to that in 1982?
Make the answer very short. 0.61. What is the ratio of the Aid flow (current US$) of Korea in 1980 to that in 1982?
Offer a terse response. 3.41. What is the ratio of the Aid flow (current US$) of Austria in 1980 to that in 1983?
Make the answer very short. 0.02. What is the ratio of the Aid flow (current US$) in Belgium in 1980 to that in 1983?
Give a very brief answer. 0.5. What is the ratio of the Aid flow (current US$) of Korea in 1980 to that in 1983?
Your answer should be compact. 0.64. What is the ratio of the Aid flow (current US$) of Austria in 1980 to that in 1984?
Give a very brief answer. 0.01. What is the ratio of the Aid flow (current US$) of Belgium in 1980 to that in 1984?
Ensure brevity in your answer.  0.4. What is the ratio of the Aid flow (current US$) in Korea in 1980 to that in 1984?
Provide a succinct answer. 0.43. What is the ratio of the Aid flow (current US$) of Austria in 1980 to that in 1985?
Your answer should be compact. 0.01. What is the ratio of the Aid flow (current US$) in Belgium in 1980 to that in 1985?
Your answer should be very brief. 0.72. What is the ratio of the Aid flow (current US$) of Korea in 1980 to that in 1985?
Provide a succinct answer. 0.34. What is the ratio of the Aid flow (current US$) of Austria in 1980 to that in 1986?
Your answer should be very brief. 0.01. What is the ratio of the Aid flow (current US$) in Belgium in 1980 to that in 1986?
Make the answer very short. 0.9. What is the ratio of the Aid flow (current US$) of Korea in 1980 to that in 1986?
Keep it short and to the point. 0.45. What is the ratio of the Aid flow (current US$) in Austria in 1980 to that in 1987?
Give a very brief answer. 0.01. What is the ratio of the Aid flow (current US$) of Belgium in 1980 to that in 1987?
Offer a terse response. 1.11. What is the ratio of the Aid flow (current US$) in Korea in 1980 to that in 1987?
Offer a very short reply. 0.4. What is the ratio of the Aid flow (current US$) of Austria in 1981 to that in 1982?
Give a very brief answer. 0.93. What is the ratio of the Aid flow (current US$) in Belgium in 1981 to that in 1982?
Provide a short and direct response. 0.65. What is the ratio of the Aid flow (current US$) in Korea in 1981 to that in 1982?
Make the answer very short. 0.41. What is the ratio of the Aid flow (current US$) in Austria in 1981 to that in 1983?
Make the answer very short. 3.04. What is the ratio of the Aid flow (current US$) of Belgium in 1981 to that in 1983?
Offer a very short reply. 0.54. What is the ratio of the Aid flow (current US$) of Korea in 1981 to that in 1983?
Offer a very short reply. 0.08. What is the ratio of the Aid flow (current US$) in Austria in 1981 to that in 1984?
Your answer should be very brief. 1.01. What is the ratio of the Aid flow (current US$) of Belgium in 1981 to that in 1984?
Your response must be concise. 0.43. What is the ratio of the Aid flow (current US$) of Korea in 1981 to that in 1984?
Provide a succinct answer. 0.05. What is the ratio of the Aid flow (current US$) of Austria in 1981 to that in 1985?
Your answer should be compact. 0.66. What is the ratio of the Aid flow (current US$) in Belgium in 1981 to that in 1985?
Provide a short and direct response. 0.77. What is the ratio of the Aid flow (current US$) of Korea in 1981 to that in 1985?
Make the answer very short. 0.04. What is the ratio of the Aid flow (current US$) in Austria in 1981 to that in 1986?
Your response must be concise. 1.01. What is the ratio of the Aid flow (current US$) in Belgium in 1981 to that in 1986?
Offer a terse response. 0.97. What is the ratio of the Aid flow (current US$) in Korea in 1981 to that in 1986?
Make the answer very short. 0.05. What is the ratio of the Aid flow (current US$) in Austria in 1981 to that in 1987?
Make the answer very short. 1.03. What is the ratio of the Aid flow (current US$) in Belgium in 1981 to that in 1987?
Make the answer very short. 1.2. What is the ratio of the Aid flow (current US$) of Korea in 1981 to that in 1987?
Provide a short and direct response. 0.05. What is the ratio of the Aid flow (current US$) of Austria in 1982 to that in 1983?
Give a very brief answer. 3.25. What is the ratio of the Aid flow (current US$) in Belgium in 1982 to that in 1983?
Provide a short and direct response. 0.83. What is the ratio of the Aid flow (current US$) of Korea in 1982 to that in 1983?
Offer a terse response. 0.19. What is the ratio of the Aid flow (current US$) in Austria in 1982 to that in 1984?
Keep it short and to the point. 1.08. What is the ratio of the Aid flow (current US$) of Belgium in 1982 to that in 1984?
Give a very brief answer. 0.66. What is the ratio of the Aid flow (current US$) of Austria in 1982 to that in 1985?
Offer a terse response. 0.71. What is the ratio of the Aid flow (current US$) of Belgium in 1982 to that in 1985?
Offer a very short reply. 1.18. What is the ratio of the Aid flow (current US$) in Korea in 1982 to that in 1985?
Keep it short and to the point. 0.1. What is the ratio of the Aid flow (current US$) of Austria in 1982 to that in 1986?
Your answer should be compact. 1.08. What is the ratio of the Aid flow (current US$) in Belgium in 1982 to that in 1986?
Keep it short and to the point. 1.48. What is the ratio of the Aid flow (current US$) of Korea in 1982 to that in 1986?
Make the answer very short. 0.13. What is the ratio of the Aid flow (current US$) of Austria in 1982 to that in 1987?
Keep it short and to the point. 1.11. What is the ratio of the Aid flow (current US$) of Belgium in 1982 to that in 1987?
Your response must be concise. 1.83. What is the ratio of the Aid flow (current US$) of Korea in 1982 to that in 1987?
Provide a short and direct response. 0.12. What is the ratio of the Aid flow (current US$) of Austria in 1983 to that in 1984?
Provide a succinct answer. 0.33. What is the ratio of the Aid flow (current US$) in Belgium in 1983 to that in 1984?
Give a very brief answer. 0.8. What is the ratio of the Aid flow (current US$) in Korea in 1983 to that in 1984?
Keep it short and to the point. 0.67. What is the ratio of the Aid flow (current US$) of Austria in 1983 to that in 1985?
Make the answer very short. 0.22. What is the ratio of the Aid flow (current US$) in Belgium in 1983 to that in 1985?
Offer a terse response. 1.43. What is the ratio of the Aid flow (current US$) in Korea in 1983 to that in 1985?
Give a very brief answer. 0.53. What is the ratio of the Aid flow (current US$) of Austria in 1983 to that in 1986?
Your answer should be compact. 0.33. What is the ratio of the Aid flow (current US$) in Belgium in 1983 to that in 1986?
Your answer should be very brief. 1.79. What is the ratio of the Aid flow (current US$) in Korea in 1983 to that in 1986?
Your answer should be very brief. 0.7. What is the ratio of the Aid flow (current US$) of Austria in 1983 to that in 1987?
Make the answer very short. 0.34. What is the ratio of the Aid flow (current US$) of Belgium in 1983 to that in 1987?
Provide a succinct answer. 2.22. What is the ratio of the Aid flow (current US$) of Korea in 1983 to that in 1987?
Ensure brevity in your answer.  0.63. What is the ratio of the Aid flow (current US$) in Austria in 1984 to that in 1985?
Ensure brevity in your answer.  0.65. What is the ratio of the Aid flow (current US$) in Belgium in 1984 to that in 1985?
Your answer should be compact. 1.78. What is the ratio of the Aid flow (current US$) of Korea in 1984 to that in 1985?
Your answer should be very brief. 0.79. What is the ratio of the Aid flow (current US$) in Austria in 1984 to that in 1986?
Offer a very short reply. 0.99. What is the ratio of the Aid flow (current US$) in Belgium in 1984 to that in 1986?
Offer a very short reply. 2.23. What is the ratio of the Aid flow (current US$) of Korea in 1984 to that in 1986?
Your response must be concise. 1.05. What is the ratio of the Aid flow (current US$) in Austria in 1984 to that in 1987?
Keep it short and to the point. 1.02. What is the ratio of the Aid flow (current US$) in Belgium in 1984 to that in 1987?
Your answer should be very brief. 2.76. What is the ratio of the Aid flow (current US$) in Korea in 1984 to that in 1987?
Provide a short and direct response. 0.94. What is the ratio of the Aid flow (current US$) of Austria in 1985 to that in 1986?
Your answer should be compact. 1.52. What is the ratio of the Aid flow (current US$) of Belgium in 1985 to that in 1986?
Provide a short and direct response. 1.26. What is the ratio of the Aid flow (current US$) of Korea in 1985 to that in 1986?
Provide a succinct answer. 1.33. What is the ratio of the Aid flow (current US$) of Austria in 1985 to that in 1987?
Make the answer very short. 1.57. What is the ratio of the Aid flow (current US$) of Belgium in 1985 to that in 1987?
Your answer should be compact. 1.55. What is the ratio of the Aid flow (current US$) of Korea in 1985 to that in 1987?
Ensure brevity in your answer.  1.2. What is the ratio of the Aid flow (current US$) of Austria in 1986 to that in 1987?
Offer a terse response. 1.03. What is the ratio of the Aid flow (current US$) of Belgium in 1986 to that in 1987?
Your answer should be very brief. 1.24. What is the ratio of the Aid flow (current US$) of Korea in 1986 to that in 1987?
Offer a very short reply. 0.9. What is the difference between the highest and the second highest Aid flow (current US$) in Austria?
Your response must be concise. 2.82e+07. What is the difference between the highest and the second highest Aid flow (current US$) of Belgium?
Your answer should be very brief. 1.01e+06. What is the difference between the highest and the second highest Aid flow (current US$) of Korea?
Provide a succinct answer. 5.70e+05. What is the difference between the highest and the lowest Aid flow (current US$) of Austria?
Make the answer very short. 9.63e+07. What is the difference between the highest and the lowest Aid flow (current US$) of Belgium?
Give a very brief answer. 3.27e+06. What is the difference between the highest and the lowest Aid flow (current US$) of Korea?
Your answer should be compact. 3.32e+06. 